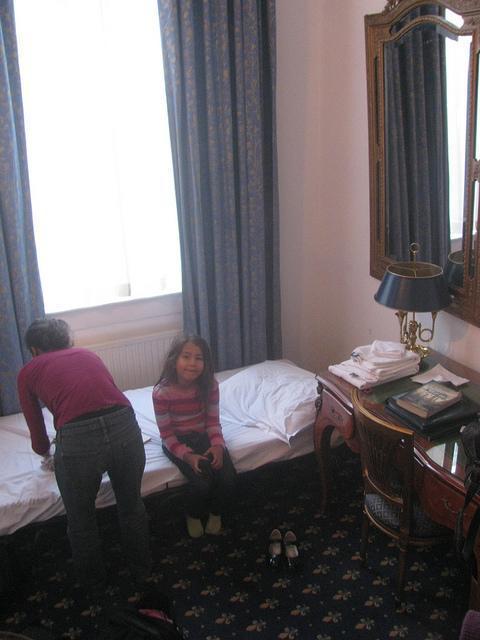How many people in the room?
Give a very brief answer. 2. How many mirrors?
Give a very brief answer. 1. How many people can be seen?
Give a very brief answer. 2. 